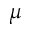<formula> <loc_0><loc_0><loc_500><loc_500>\mu</formula> 